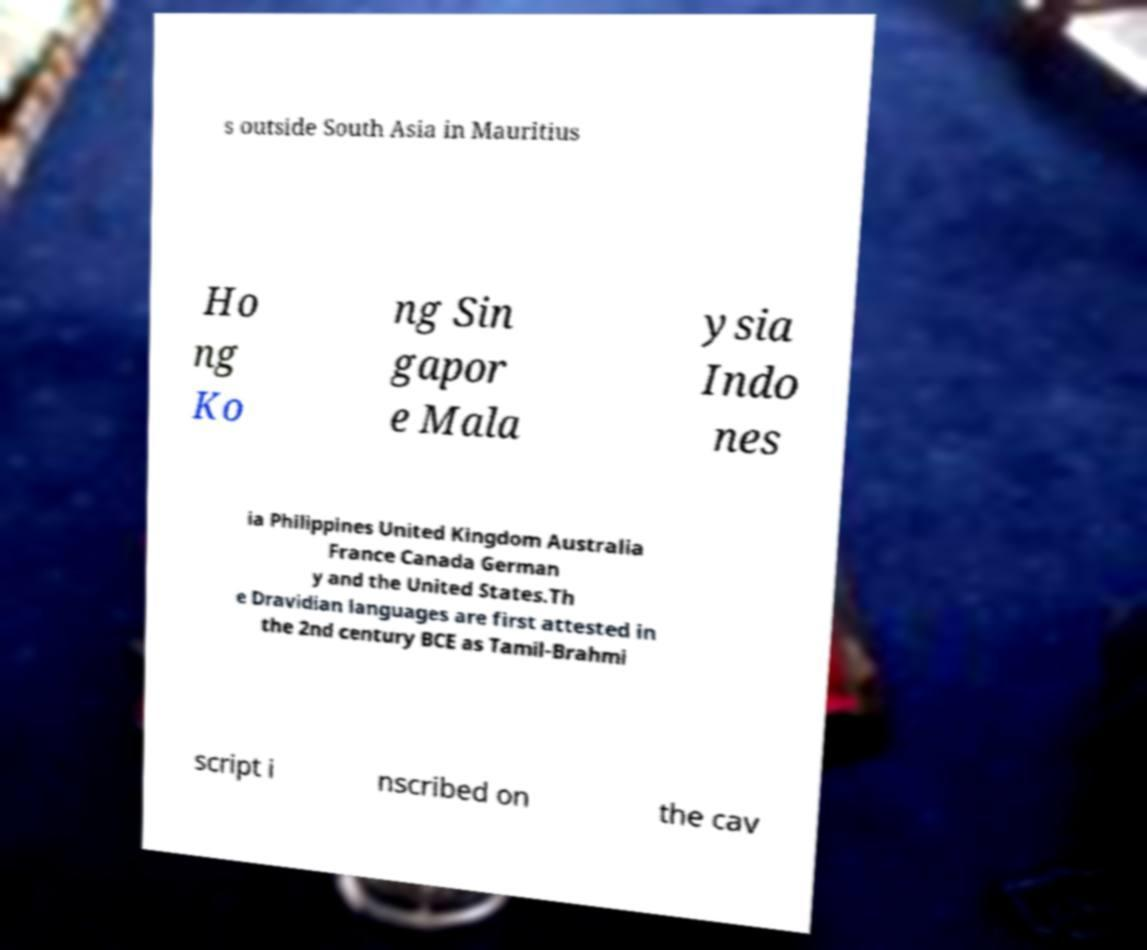Could you assist in decoding the text presented in this image and type it out clearly? s outside South Asia in Mauritius Ho ng Ko ng Sin gapor e Mala ysia Indo nes ia Philippines United Kingdom Australia France Canada German y and the United States.Th e Dravidian languages are first attested in the 2nd century BCE as Tamil-Brahmi script i nscribed on the cav 